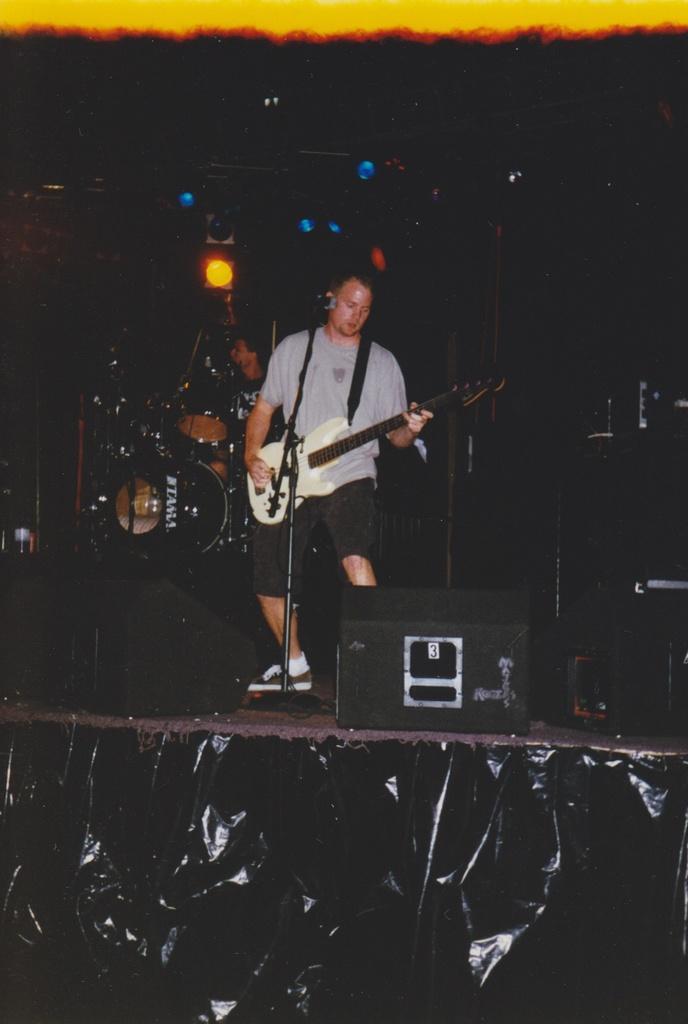Can you describe this image briefly? In the middle, a person is standing in front of the mike and playing a guitar. Next to that a speaker is there. On the top left, focus lights are visible. The background is dark in color. Behind that a person is playing musical instruments in the middle. This image is taken on the stage during night time. 